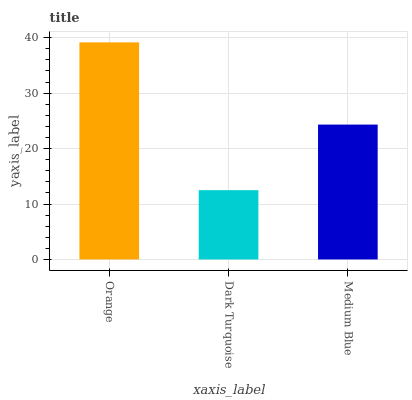Is Medium Blue the minimum?
Answer yes or no. No. Is Medium Blue the maximum?
Answer yes or no. No. Is Medium Blue greater than Dark Turquoise?
Answer yes or no. Yes. Is Dark Turquoise less than Medium Blue?
Answer yes or no. Yes. Is Dark Turquoise greater than Medium Blue?
Answer yes or no. No. Is Medium Blue less than Dark Turquoise?
Answer yes or no. No. Is Medium Blue the high median?
Answer yes or no. Yes. Is Medium Blue the low median?
Answer yes or no. Yes. Is Orange the high median?
Answer yes or no. No. Is Dark Turquoise the low median?
Answer yes or no. No. 